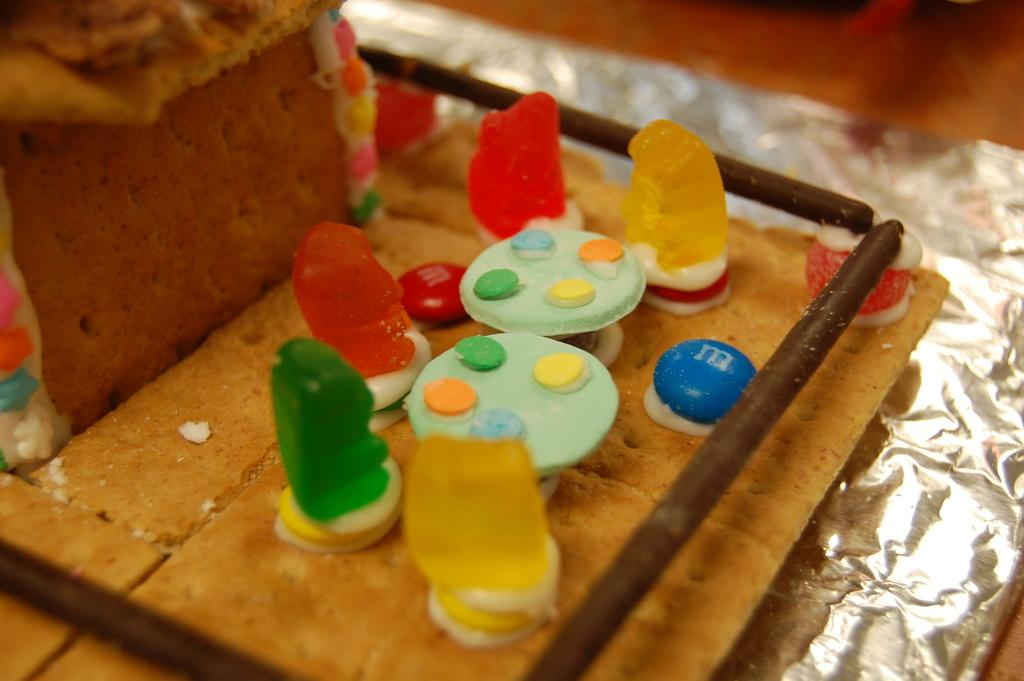What type of topping can be seen on the cake in the image? There are jelly's on the cake in the image. What else is present on the cake besides the jelly's? There are germs on the cake. What can be seen around the cake in the image? There are chocolate sticks around the cake. What type of harmony can be heard in the background of the image? There is no audible harmony in the image, as it is a still image of a cake. 